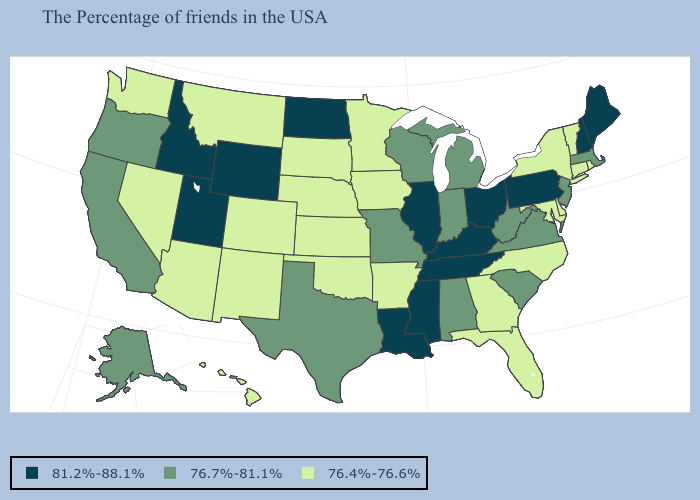Name the states that have a value in the range 76.7%-81.1%?
Concise answer only. Massachusetts, New Jersey, Virginia, South Carolina, West Virginia, Michigan, Indiana, Alabama, Wisconsin, Missouri, Texas, California, Oregon, Alaska. Name the states that have a value in the range 76.7%-81.1%?
Short answer required. Massachusetts, New Jersey, Virginia, South Carolina, West Virginia, Michigan, Indiana, Alabama, Wisconsin, Missouri, Texas, California, Oregon, Alaska. What is the value of North Carolina?
Short answer required. 76.4%-76.6%. What is the highest value in the USA?
Answer briefly. 81.2%-88.1%. Name the states that have a value in the range 76.7%-81.1%?
Short answer required. Massachusetts, New Jersey, Virginia, South Carolina, West Virginia, Michigan, Indiana, Alabama, Wisconsin, Missouri, Texas, California, Oregon, Alaska. Name the states that have a value in the range 76.7%-81.1%?
Give a very brief answer. Massachusetts, New Jersey, Virginia, South Carolina, West Virginia, Michigan, Indiana, Alabama, Wisconsin, Missouri, Texas, California, Oregon, Alaska. What is the value of North Dakota?
Answer briefly. 81.2%-88.1%. Does the first symbol in the legend represent the smallest category?
Quick response, please. No. What is the lowest value in the USA?
Give a very brief answer. 76.4%-76.6%. What is the highest value in the USA?
Keep it brief. 81.2%-88.1%. Name the states that have a value in the range 76.7%-81.1%?
Write a very short answer. Massachusetts, New Jersey, Virginia, South Carolina, West Virginia, Michigan, Indiana, Alabama, Wisconsin, Missouri, Texas, California, Oregon, Alaska. What is the value of Delaware?
Short answer required. 76.4%-76.6%. What is the value of Minnesota?
Short answer required. 76.4%-76.6%. Is the legend a continuous bar?
Answer briefly. No. Among the states that border Oklahoma , which have the lowest value?
Answer briefly. Arkansas, Kansas, Colorado, New Mexico. 